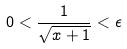Convert formula to latex. <formula><loc_0><loc_0><loc_500><loc_500>0 < \frac { 1 } { \sqrt { x + 1 } } < \epsilon</formula> 